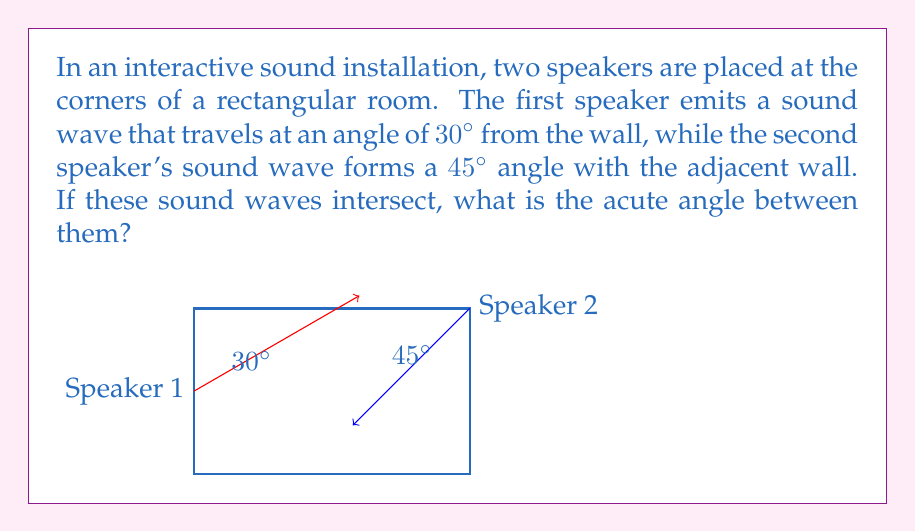What is the answer to this math problem? Let's approach this step-by-step:

1) First, we need to understand what the question is asking. We're looking for the acute angle between two intersecting sound waves.

2) The direction of a sound wave can be represented by a vector. In this case, we have two vectors:
   - Vector 1: $30°$ from the wall (or $30°$ from the positive x-axis)
   - Vector 2: $45°$ from the adjacent wall (or $45°$ from the negative y-axis, which is equivalent to $225°$ from the positive x-axis)

3) To find the angle between these vectors, we can use the formula:

   $$ \theta = |\alpha - \beta| $$

   Where $\theta$ is the angle between the vectors, and $\alpha$ and $\beta$ are the angles of the vectors from the positive x-axis.

4) In this case:
   $\alpha = 30°$
   $\beta = 225°$

5) Plugging these into our formula:

   $$ \theta = |30° - 225°| = 195° $$

6) However, the question asks for the acute angle. The acute angle is always less than or equal to $90°$. If our calculated angle is greater than $180°$, we can find the acute angle by subtracting it from $360°$:

   $$ \text{Acute angle} = 360° - 195° = 165° $$

7) Therefore, the acute angle between the sound waves is $165°$.
Answer: $165°$ 